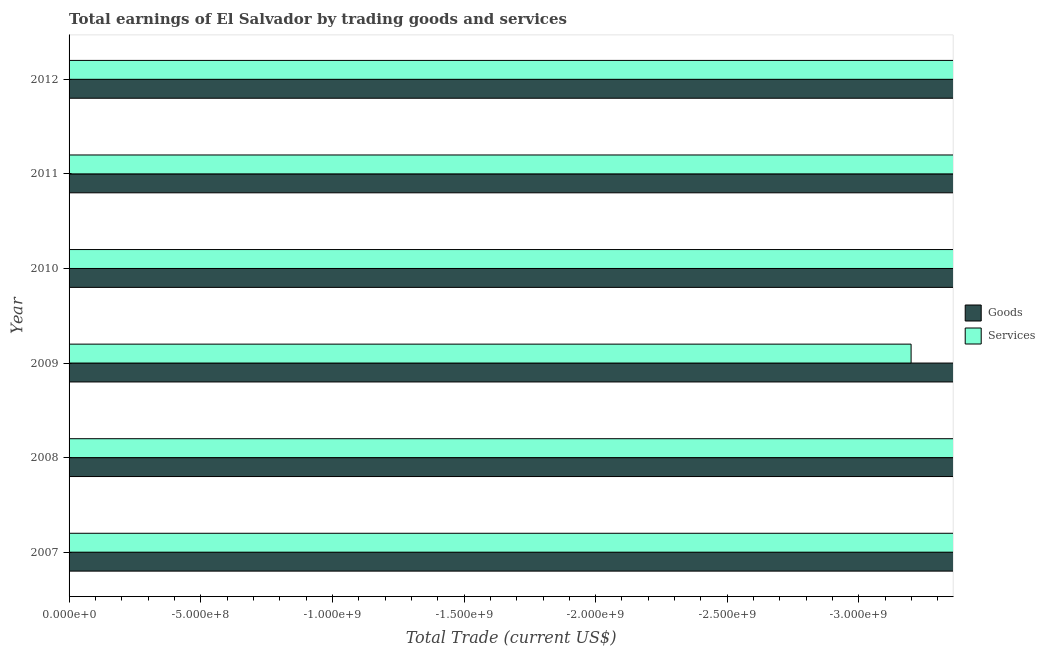Are the number of bars per tick equal to the number of legend labels?
Provide a short and direct response. No. Are the number of bars on each tick of the Y-axis equal?
Provide a short and direct response. Yes. How many bars are there on the 4th tick from the top?
Provide a succinct answer. 0. How many bars are there on the 3rd tick from the bottom?
Provide a succinct answer. 0. What is the amount earned by trading goods in 2007?
Provide a short and direct response. 0. What is the difference between the amount earned by trading services in 2009 and the amount earned by trading goods in 2012?
Provide a succinct answer. 0. What is the average amount earned by trading services per year?
Offer a terse response. 0. How many bars are there?
Ensure brevity in your answer.  0. Are all the bars in the graph horizontal?
Offer a very short reply. Yes. How many years are there in the graph?
Offer a very short reply. 6. Does the graph contain grids?
Provide a short and direct response. No. Where does the legend appear in the graph?
Give a very brief answer. Center right. What is the title of the graph?
Your response must be concise. Total earnings of El Salvador by trading goods and services. What is the label or title of the X-axis?
Ensure brevity in your answer.  Total Trade (current US$). What is the Total Trade (current US$) of Services in 2007?
Your answer should be very brief. 0. What is the Total Trade (current US$) of Goods in 2008?
Ensure brevity in your answer.  0. What is the Total Trade (current US$) in Services in 2008?
Your response must be concise. 0. What is the Total Trade (current US$) of Goods in 2010?
Provide a short and direct response. 0. What is the Total Trade (current US$) in Services in 2010?
Your answer should be compact. 0. What is the Total Trade (current US$) of Services in 2012?
Ensure brevity in your answer.  0. What is the total Total Trade (current US$) of Goods in the graph?
Your answer should be compact. 0. What is the total Total Trade (current US$) of Services in the graph?
Provide a short and direct response. 0. What is the average Total Trade (current US$) of Services per year?
Your answer should be compact. 0. 